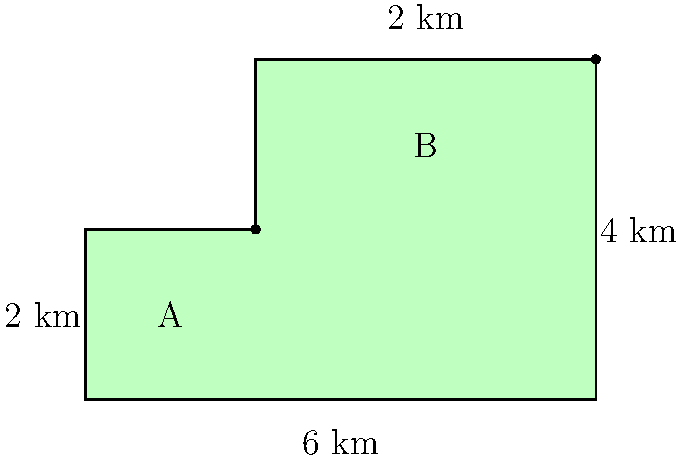A new polder in the Netherlands has been created with the shape shown in the diagram. If the total perimeter of the polder is 20 km, what is its area in square kilometers? To solve this problem, we'll follow these steps:

1) First, we need to identify the shape. The polder is composed of a rectangle (A) and a smaller rectangle (B) on top.

2) We can calculate the dimensions of the polder using the given information:
   - The width of the polder is 6 km
   - The total height is 4 km
   - The width of the upper rectangle (B) is 4 km (6 km - 2 km)
   - The height of the lower rectangle (A) is 2 km

3) Now, we can calculate the areas of both rectangles:
   Area of A: $6 \text{ km} \times 2 \text{ km} = 12 \text{ km}^2$
   Area of B: $4 \text{ km} \times 2 \text{ km} = 8 \text{ km}^2$

4) The total area is the sum of these two areas:
   Total Area $= 12 \text{ km}^2 + 8 \text{ km}^2 = 20 \text{ km}^2$

5) To verify, we can check if the perimeter matches the given 20 km:
   Perimeter $= 6 \text{ km} + 4 \text{ km} + 4 \text{ km} + 2 \text{ km} + 2 \text{ km} + 2 \text{ km} = 20 \text{ km}$

Therefore, the area of the polder is 20 square kilometers.
Answer: 20 km² 